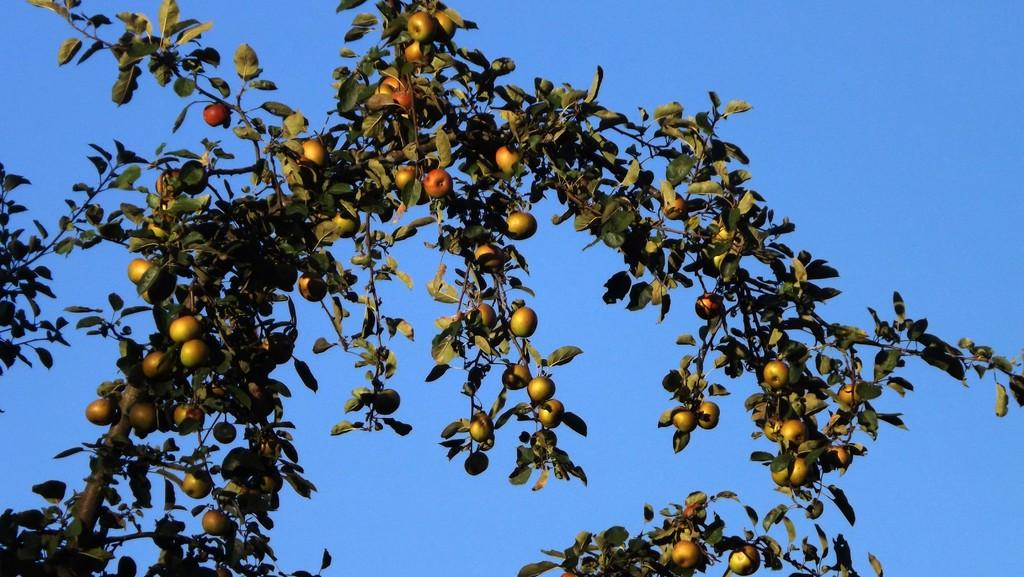What is the main object in the image? There is a tree in the image. What is on the tree? There are fruits on the tree. What can be seen in the background of the image? There is a sky visible in the background of the image. How many beads are hanging from the tree in the image? There are no beads present in the image; it features a tree with fruits. 